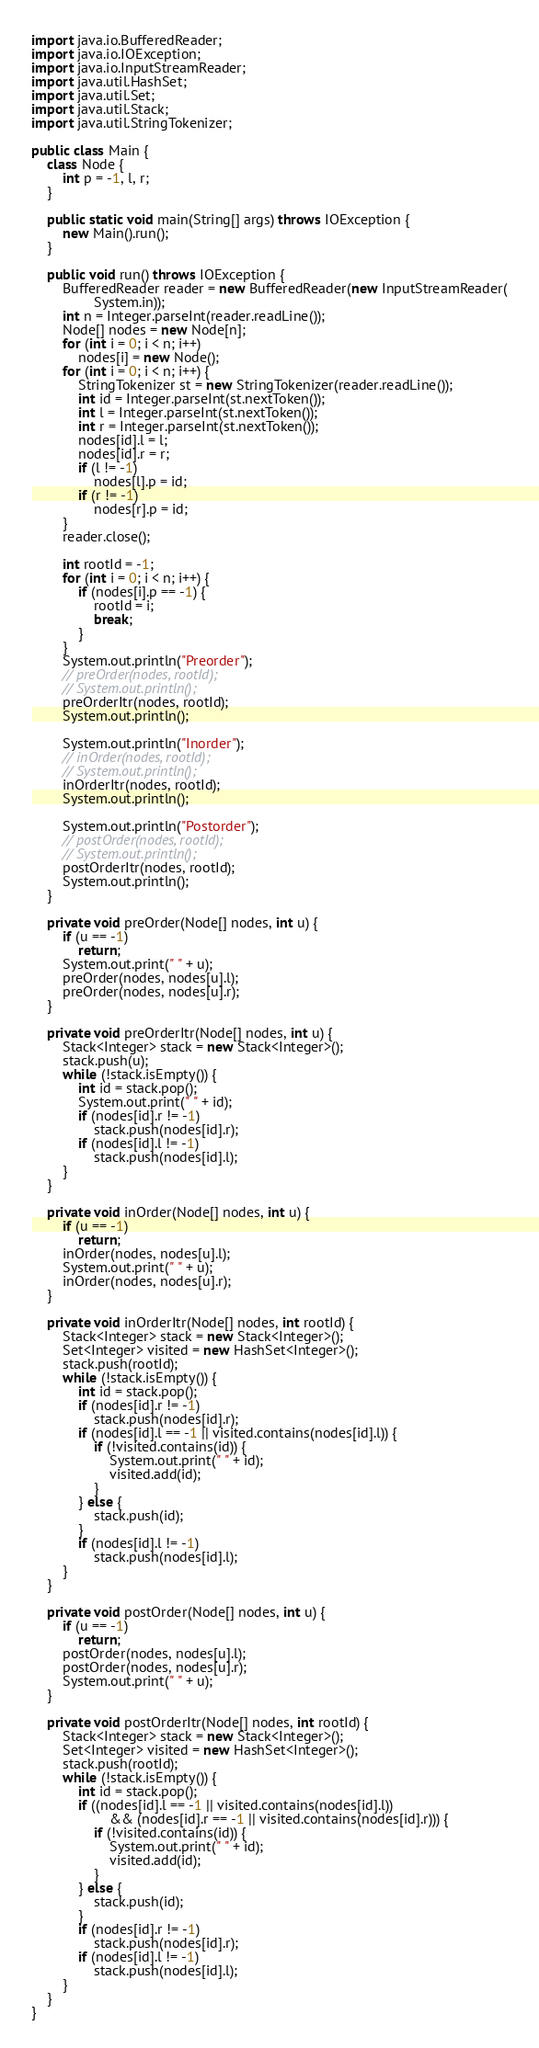Convert code to text. <code><loc_0><loc_0><loc_500><loc_500><_Java_>import java.io.BufferedReader;
import java.io.IOException;
import java.io.InputStreamReader;
import java.util.HashSet;
import java.util.Set;
import java.util.Stack;
import java.util.StringTokenizer;

public class Main {
	class Node {
		int p = -1, l, r;
	}

	public static void main(String[] args) throws IOException {
		new Main().run();
	}

	public void run() throws IOException {
		BufferedReader reader = new BufferedReader(new InputStreamReader(
				System.in));
		int n = Integer.parseInt(reader.readLine());
		Node[] nodes = new Node[n];
		for (int i = 0; i < n; i++)
			nodes[i] = new Node();
		for (int i = 0; i < n; i++) {
			StringTokenizer st = new StringTokenizer(reader.readLine());
			int id = Integer.parseInt(st.nextToken());
			int l = Integer.parseInt(st.nextToken());
			int r = Integer.parseInt(st.nextToken());
			nodes[id].l = l;
			nodes[id].r = r;
			if (l != -1)
				nodes[l].p = id;
			if (r != -1)
				nodes[r].p = id;
		}
		reader.close();

		int rootId = -1;
		for (int i = 0; i < n; i++) {
			if (nodes[i].p == -1) {
				rootId = i;
				break;
			}
		}
		System.out.println("Preorder");
		// preOrder(nodes, rootId);
		// System.out.println();
		preOrderItr(nodes, rootId);
		System.out.println();

		System.out.println("Inorder");
		// inOrder(nodes, rootId);
		// System.out.println();
		inOrderItr(nodes, rootId);
		System.out.println();

		System.out.println("Postorder");
		// postOrder(nodes, rootId);
		// System.out.println();
		postOrderItr(nodes, rootId);
		System.out.println();
	}

	private void preOrder(Node[] nodes, int u) {
		if (u == -1)
			return;
		System.out.print(" " + u);
		preOrder(nodes, nodes[u].l);
		preOrder(nodes, nodes[u].r);
	}

	private void preOrderItr(Node[] nodes, int u) {
		Stack<Integer> stack = new Stack<Integer>();
		stack.push(u);
		while (!stack.isEmpty()) {
			int id = stack.pop();
			System.out.print(" " + id);
			if (nodes[id].r != -1)
				stack.push(nodes[id].r);
			if (nodes[id].l != -1)
				stack.push(nodes[id].l);
		}
	}

	private void inOrder(Node[] nodes, int u) {
		if (u == -1)
			return;
		inOrder(nodes, nodes[u].l);
		System.out.print(" " + u);
		inOrder(nodes, nodes[u].r);
	}

	private void inOrderItr(Node[] nodes, int rootId) {
		Stack<Integer> stack = new Stack<Integer>();
		Set<Integer> visited = new HashSet<Integer>();
		stack.push(rootId);
		while (!stack.isEmpty()) {
			int id = stack.pop();
			if (nodes[id].r != -1)
				stack.push(nodes[id].r);
			if (nodes[id].l == -1 || visited.contains(nodes[id].l)) {
				if (!visited.contains(id)) {
					System.out.print(" " + id);
					visited.add(id);
				}
			} else {
				stack.push(id);
			}
			if (nodes[id].l != -1)
				stack.push(nodes[id].l);
		}
	}

	private void postOrder(Node[] nodes, int u) {
		if (u == -1)
			return;
		postOrder(nodes, nodes[u].l);
		postOrder(nodes, nodes[u].r);
		System.out.print(" " + u);
	}

	private void postOrderItr(Node[] nodes, int rootId) {
		Stack<Integer> stack = new Stack<Integer>();
		Set<Integer> visited = new HashSet<Integer>();
		stack.push(rootId);
		while (!stack.isEmpty()) {
			int id = stack.pop();
			if ((nodes[id].l == -1 || visited.contains(nodes[id].l))
					&& (nodes[id].r == -1 || visited.contains(nodes[id].r))) {
				if (!visited.contains(id)) {
					System.out.print(" " + id);
					visited.add(id);
				}
			} else {
				stack.push(id);
			}
			if (nodes[id].r != -1)
				stack.push(nodes[id].r);
			if (nodes[id].l != -1)
				stack.push(nodes[id].l);
		}
	}
}

</code> 